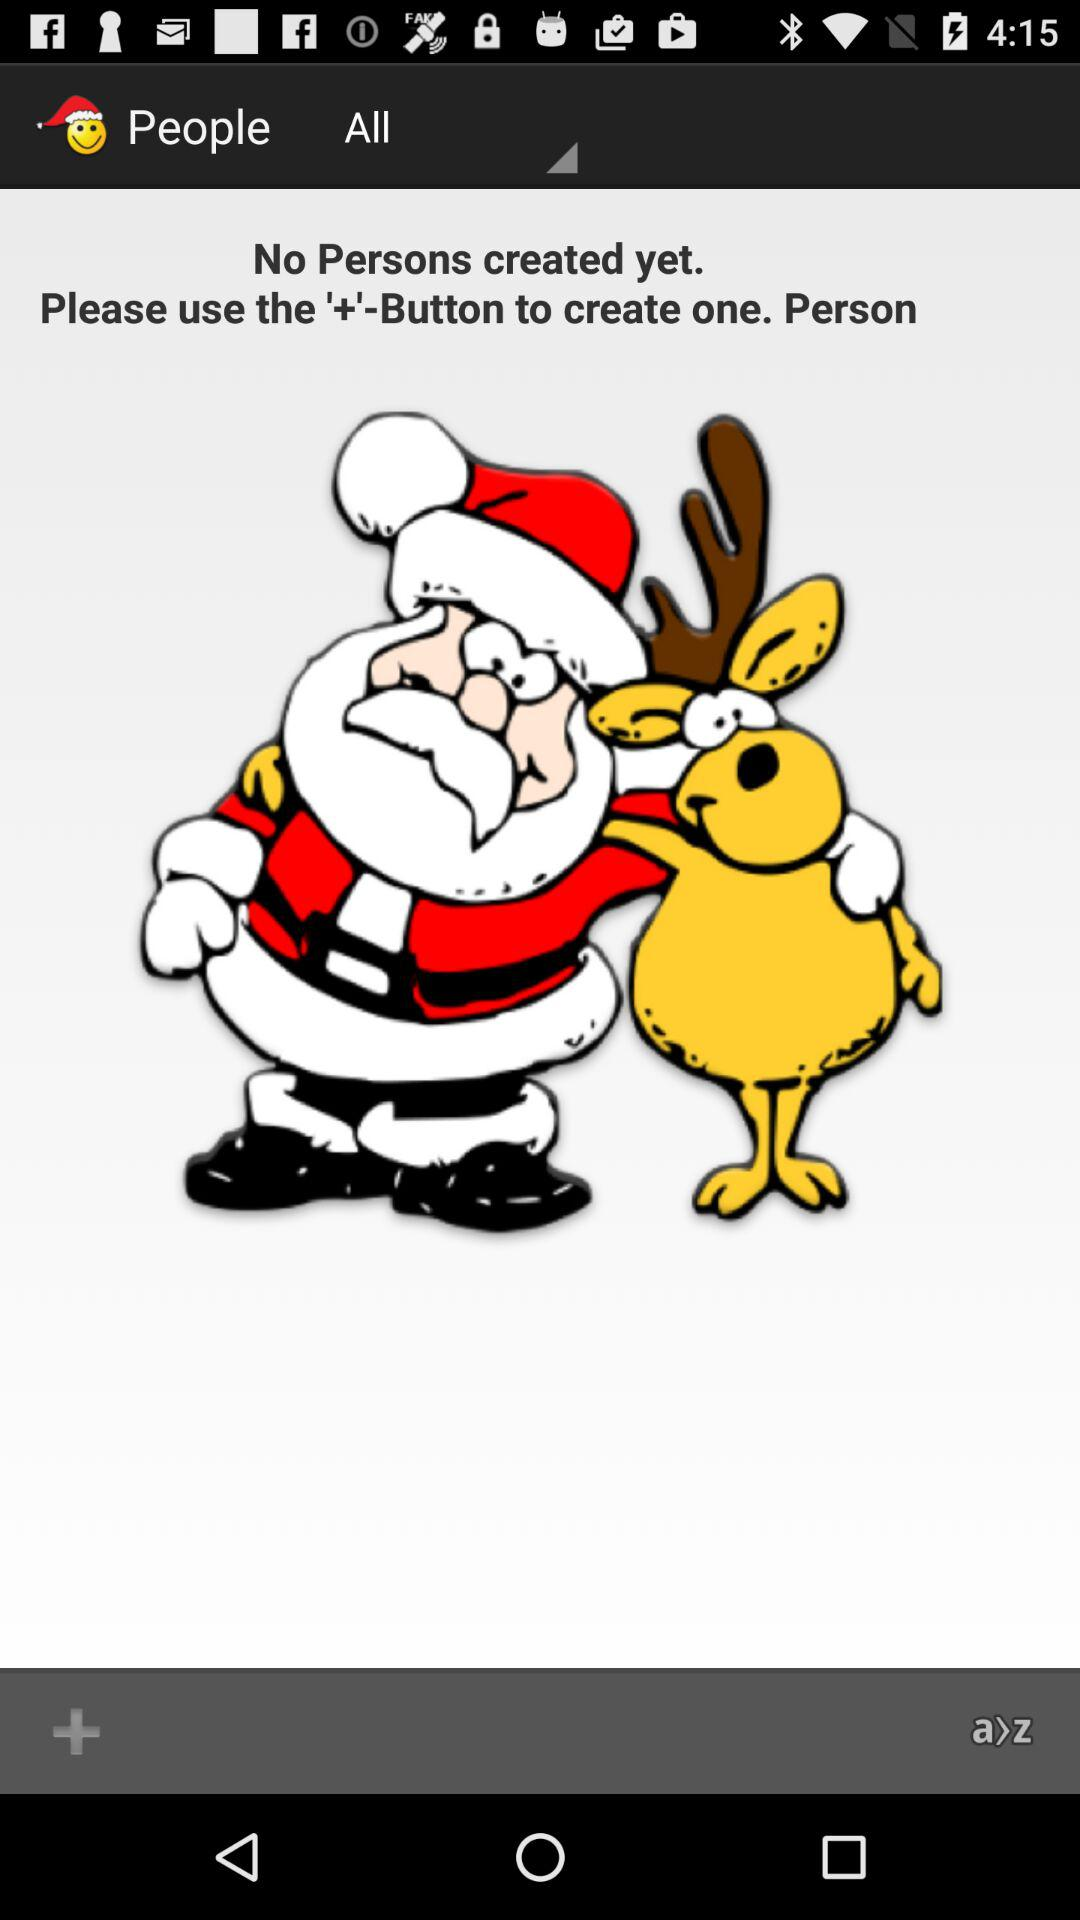Which options are available in the drop-down menu?
When the provided information is insufficient, respond with <no answer>. <no answer> 